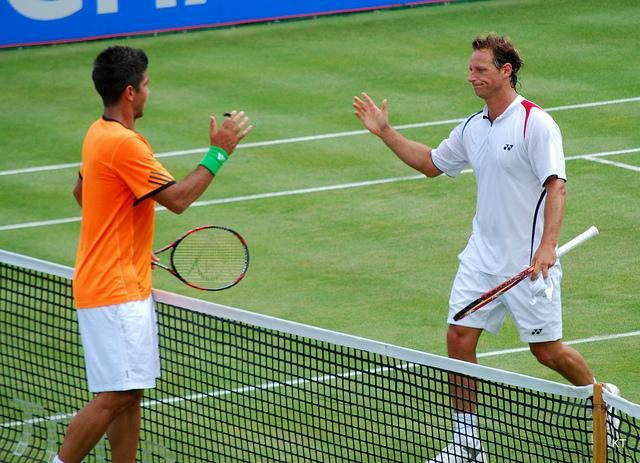What is the name of a famous player of this sport? andre agassi 